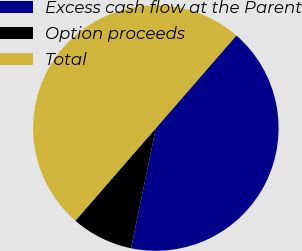<chart> <loc_0><loc_0><loc_500><loc_500><pie_chart><fcel>Excess cash flow at the Parent<fcel>Option proceeds<fcel>Total<nl><fcel>41.85%<fcel>8.15%<fcel>50.0%<nl></chart> 